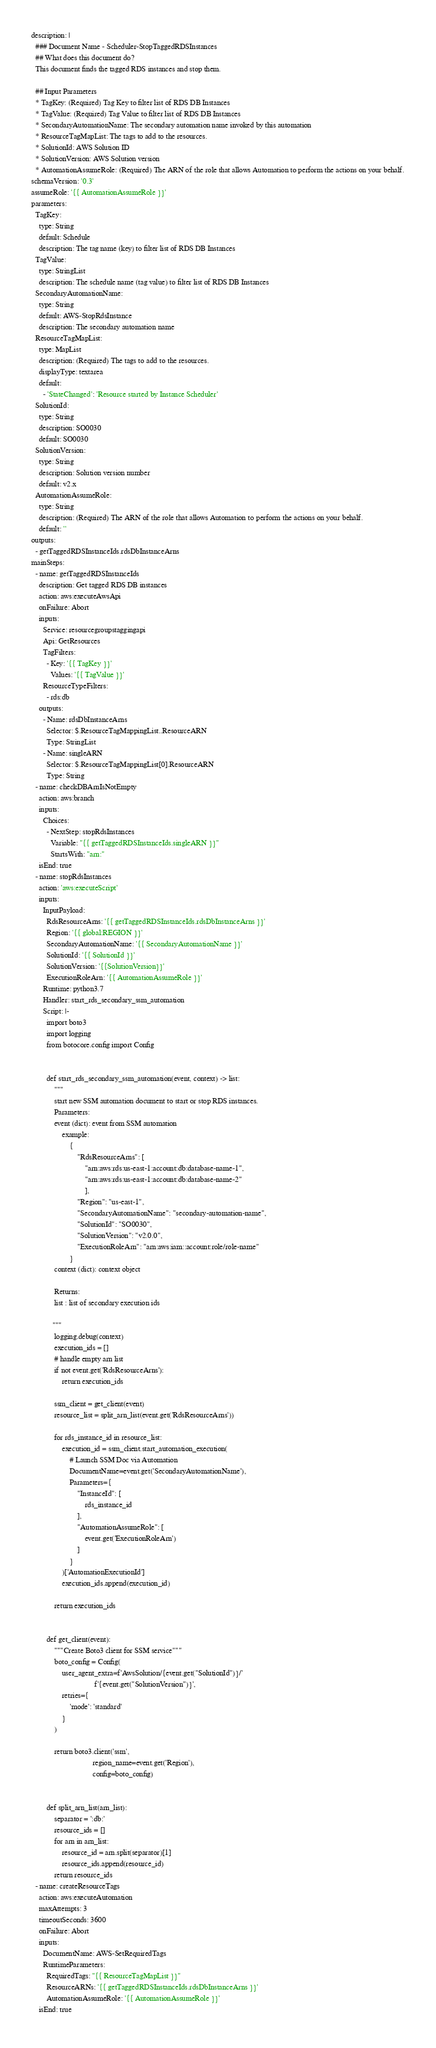Convert code to text. <code><loc_0><loc_0><loc_500><loc_500><_YAML_>description: |
  ### Document Name - Scheduler-StopTaggedRDSInstances
  ## What does this document do?
  This document finds the tagged RDS instances and stop them.

  ## Input Parameters
  * TagKey: (Required) Tag Key to filter list of RDS DB Instances
  * TagValue: (Required) Tag Value to filter list of RDS DB Instances
  * SecondaryAutomationName: The secondary automation name invoked by this automation
  * ResourceTagMapList: The tags to add to the resources.
  * SolutionId: AWS Solution ID
  * SolutionVersion: AWS Solution version
  * AutomationAssumeRole: (Required) The ARN of the role that allows Automation to perform the actions on your behalf.
schemaVersion: '0.3'
assumeRole: '{{ AutomationAssumeRole }}'
parameters:
  TagKey:
    type: String
    default: Schedule
    description: The tag name (key) to filter list of RDS DB Instances
  TagValue:
    type: StringList
    description: The schedule name (tag value) to filter list of RDS DB Instances
  SecondaryAutomationName:
    type: String
    default: AWS-StopRdsInstance
    description: The secondary automation name
  ResourceTagMapList:
    type: MapList
    description: (Required) The tags to add to the resources.
    displayType: textarea
    default:
      - 'StateChanged': 'Resource started by Instance Scheduler'
  SolutionId:
    type: String
    description: SO0030
    default: SO0030
  SolutionVersion:
    type: String
    description: Solution version number
    default: v2.x
  AutomationAssumeRole:
    type: String
    description: (Required) The ARN of the role that allows Automation to perform the actions on your behalf.
    default: ''
outputs:
  - getTaggedRDSInstanceIds.rdsDbInstanceArns
mainSteps:
  - name: getTaggedRDSInstanceIds
    description: Get tagged RDS DB instances
    action: aws:executeAwsApi
    onFailure: Abort
    inputs:
      Service: resourcegroupstaggingapi
      Api: GetResources
      TagFilters:
        - Key: '{{ TagKey }}'
          Values: '{{ TagValue }}'
      ResourceTypeFilters:
        - rds:db
    outputs:
      - Name: rdsDbInstanceArns
        Selector: $.ResourceTagMappingList..ResourceARN
        Type: StringList
      - Name: singleARN
        Selector: $.ResourceTagMappingList[0].ResourceARN
        Type: String
  - name: checkDBArnIsNotEmpty
    action: aws:branch
    inputs:
      Choices:
        - NextStep: stopRdsInstances
          Variable: "{{ getTaggedRDSInstanceIds.singleARN }}"
          StartsWith: "arn:"
    isEnd: true
  - name: stopRdsInstances
    action: 'aws:executeScript'
    inputs:
      InputPayload:
        RdsResourceArns: '{{ getTaggedRDSInstanceIds.rdsDbInstanceArns }}'
        Region: '{{ global:REGION }}'
        SecondaryAutomationName: '{{ SecondaryAutomationName }}'
        SolutionId: '{{ SolutionId }}'
        SolutionVersion: '{{SolutionVersion}}'
        ExecutionRoleArn: '{{ AutomationAssumeRole }}'
      Runtime: python3.7
      Handler: start_rds_secondary_ssm_automation
      Script: |-
        import boto3
        import logging
        from botocore.config import Config


        def start_rds_secondary_ssm_automation(event, context) -> list:
            """
            start new SSM automation document to start or stop RDS instances.
            Parameters:
            event (dict): event from SSM automation
                example:
                    {
                        "RdsResourceArns": [
                            "arn:aws:rds:us-east-1:account:db:database-name-1",
                            "arn:aws:rds:us-east-1:account:db:database-name-2"
                            ],
                        "Region": "us-east-1",
                        "SecondaryAutomationName": "secondary-automation-name",
                        "SolutionId": "SO0030",
                        "SolutionVersion": "v2.0.0",
                        "ExecutionRoleArn": "arn:aws:iam::account:role/role-name"
                    }
            context (dict): context object

            Returns:
            list : list of secondary execution ids

           """
            logging.debug(context)
            execution_ids = []
            # handle empty arn list
            if not event.get('RdsResourceArns'):
                return execution_ids

            ssm_client = get_client(event)
            resource_list = split_arn_list(event.get('RdsResourceArns'))

            for rds_instance_id in resource_list:
                execution_id = ssm_client.start_automation_execution(
                    # Launch SSM Doc via Automation
                    DocumentName=event.get('SecondaryAutomationName'),
                    Parameters={
                        "InstanceId": [
                            rds_instance_id
                        ],
                        "AutomationAssumeRole": [
                            event.get('ExecutionRoleArn')
                        ]
                    }
                )['AutomationExecutionId']
                execution_ids.append(execution_id)

            return execution_ids


        def get_client(event):
            """Create Boto3 client for SSM service"""
            boto_config = Config(
                user_agent_extra=f'AwsSolution/{event.get("SolutionId")}/'
                                 f'{event.get("SolutionVersion")}',
                retries={
                    'mode': 'standard'
                }
            )

            return boto3.client('ssm',
                                region_name=event.get('Region'),
                                config=boto_config)


        def split_arn_list(arn_list):
            separator = ':db:'
            resource_ids = []
            for arn in arn_list:
                resource_id = arn.split(separator)[1]
                resource_ids.append(resource_id)
            return resource_ids
  - name: createResourceTags
    action: aws:executeAutomation
    maxAttempts: 3
    timeoutSeconds: 3600
    onFailure: Abort
    inputs:
      DocumentName: AWS-SetRequiredTags
      RuntimeParameters:
        RequiredTags: "{{ ResourceTagMapList }}"
        ResourceARNs: '{{ getTaggedRDSInstanceIds.rdsDbInstanceArns }}'
        AutomationAssumeRole: '{{ AutomationAssumeRole }}'
    isEnd: true
</code> 